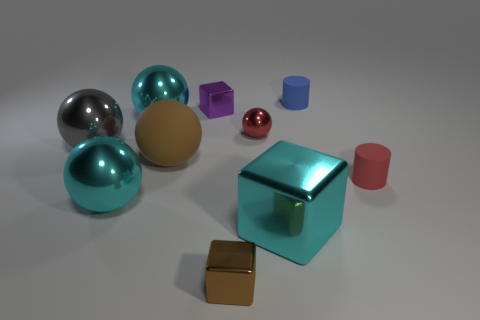Subtract all brown balls. How many balls are left? 4 Subtract all big gray shiny balls. How many balls are left? 4 Subtract all purple balls. Subtract all yellow blocks. How many balls are left? 5 Subtract all cylinders. How many objects are left? 8 Subtract all small brown cubes. Subtract all large cyan metallic balls. How many objects are left? 7 Add 3 big metallic cubes. How many big metallic cubes are left? 4 Add 2 tiny blue objects. How many tiny blue objects exist? 3 Subtract 0 brown cylinders. How many objects are left? 10 